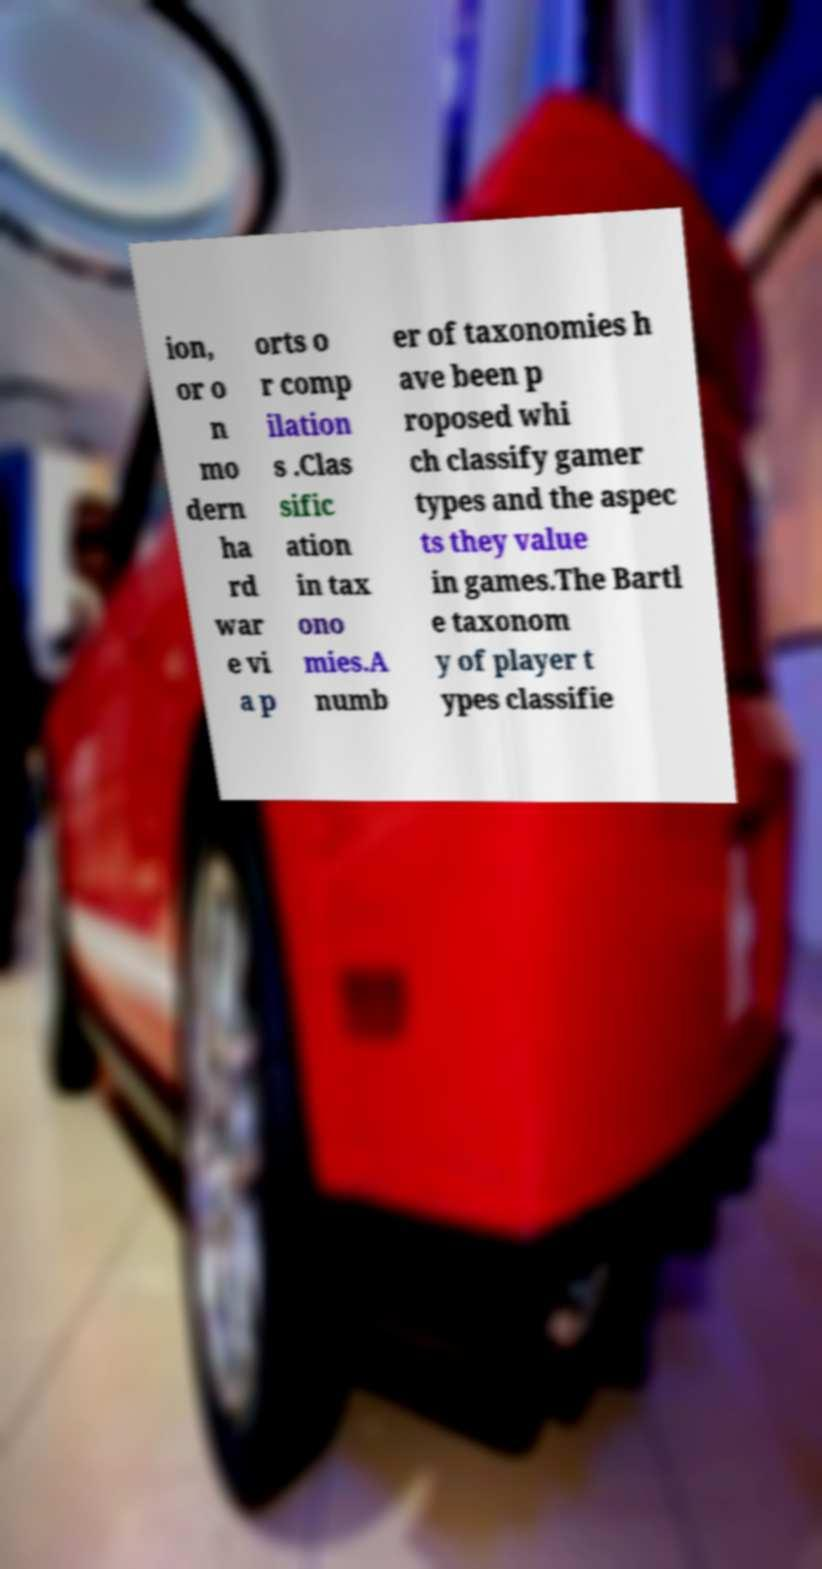There's text embedded in this image that I need extracted. Can you transcribe it verbatim? ion, or o n mo dern ha rd war e vi a p orts o r comp ilation s .Clas sific ation in tax ono mies.A numb er of taxonomies h ave been p roposed whi ch classify gamer types and the aspec ts they value in games.The Bartl e taxonom y of player t ypes classifie 